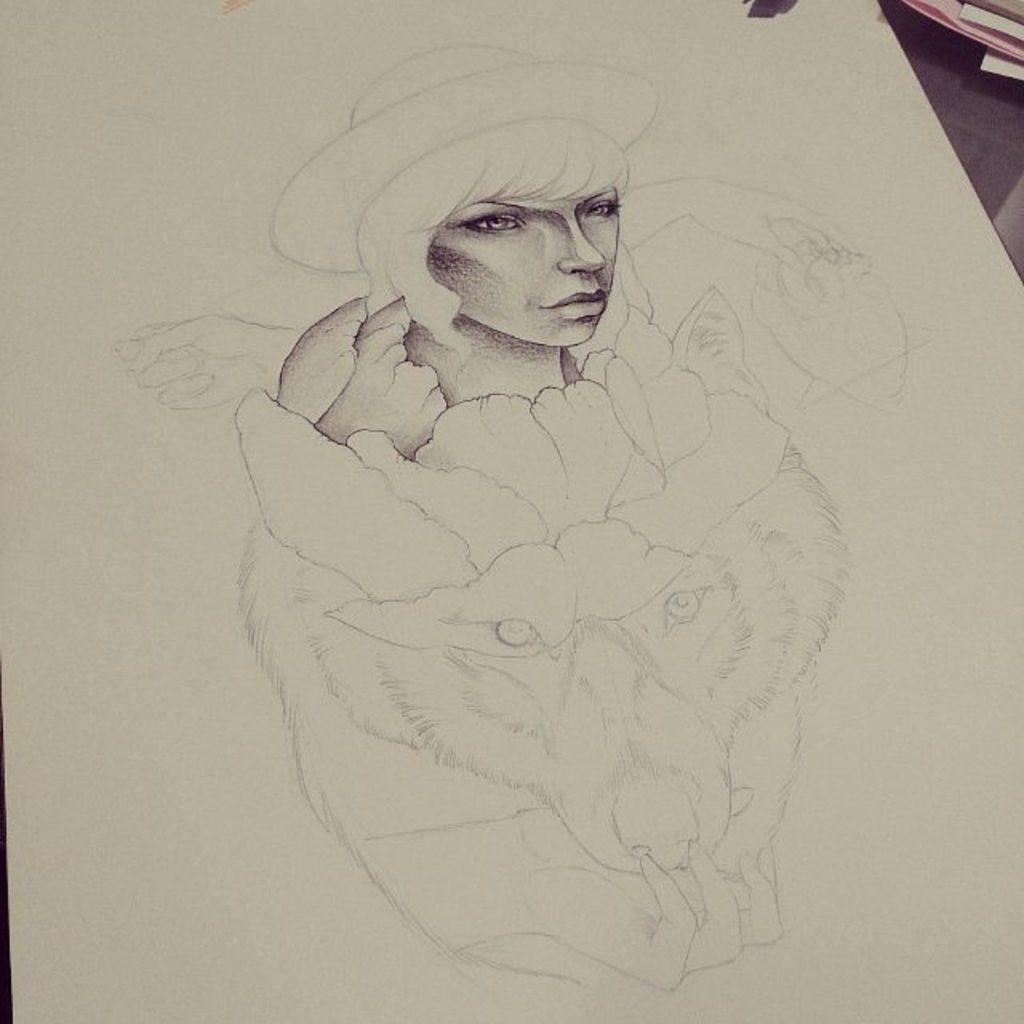What is depicted on the white paper in the image? There is a pencil drawing on a white paper. What subjects are included in the drawing? The drawing contains a person and an animal face. How does the person in the drawing rest their hand on the animal's head? There is no hand resting on the animal's head in the drawing; it only contains a person and an animal face. 